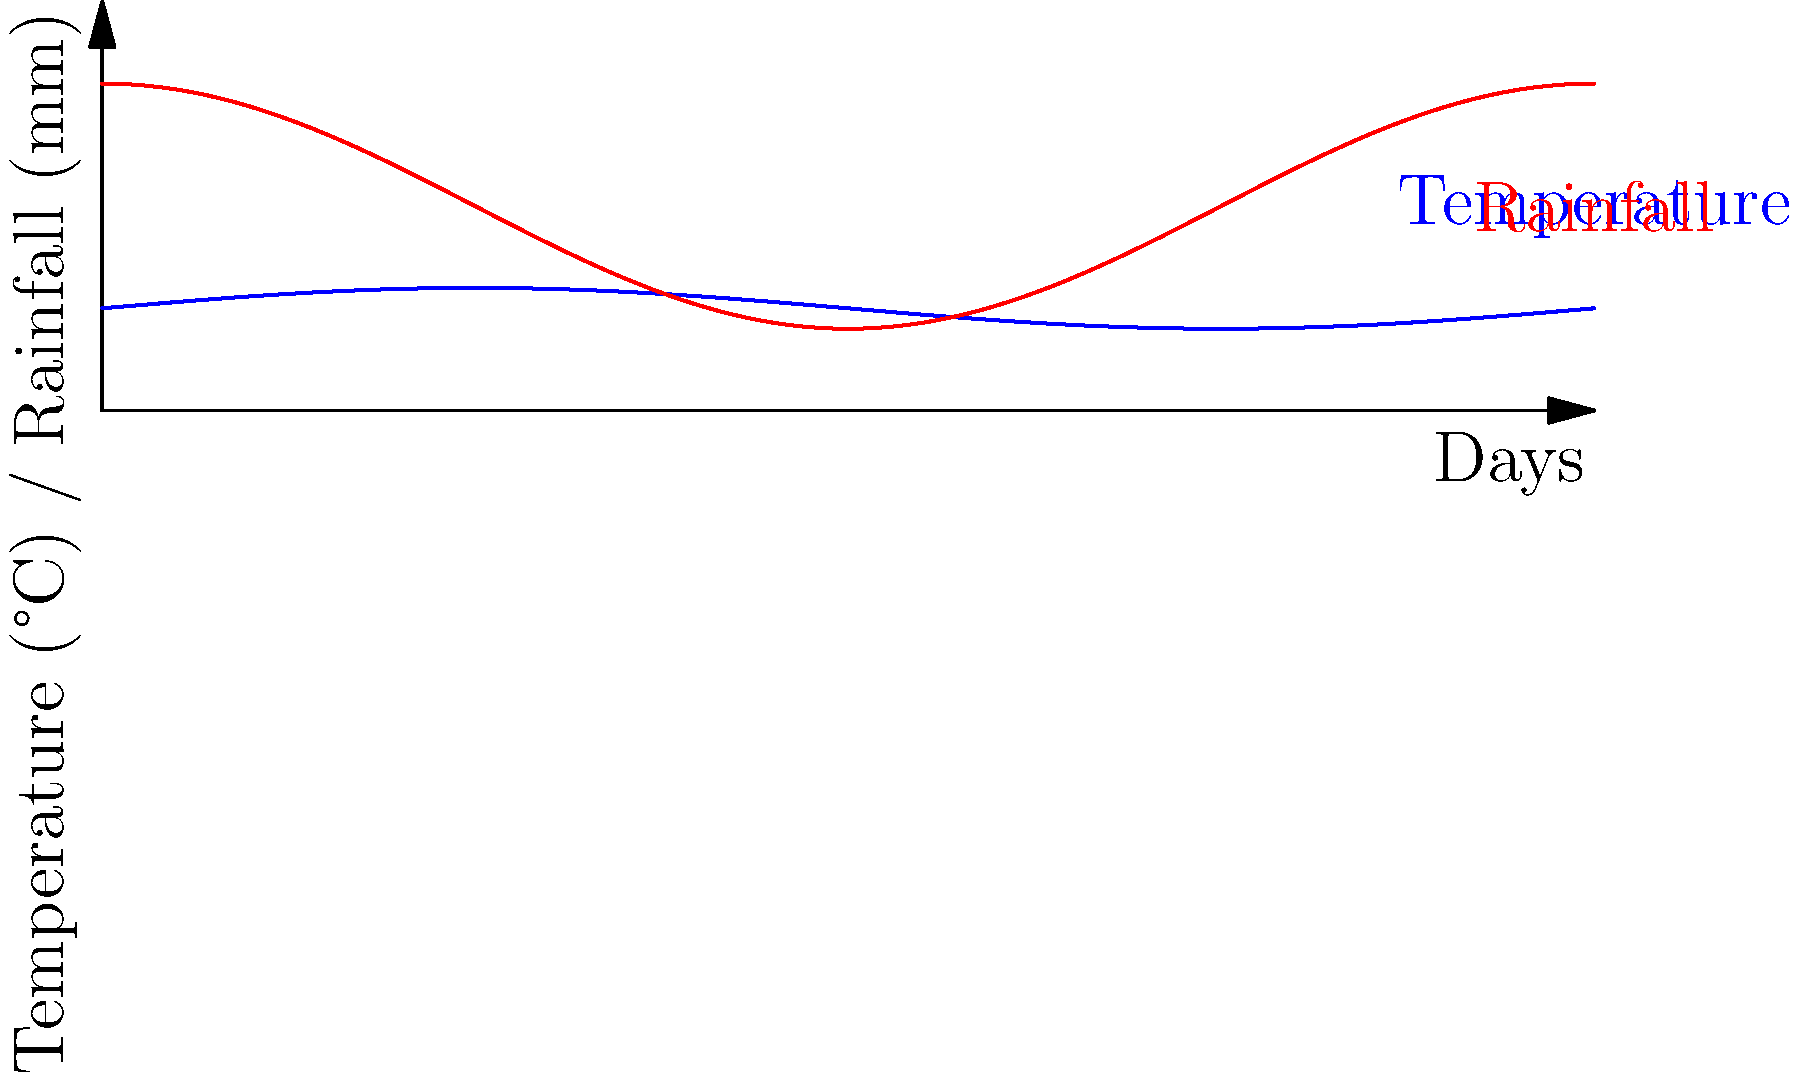As a farmer using genetically modified crops, you're analyzing the relationship between weather patterns and crop yield. The graph shows sinusoidal functions representing temperature (blue) and rainfall (red) over a year. The temperature function is given by $T(d) = 25 + 5\sin(\frac{2\pi d}{365})$, where $T$ is temperature in °C and $d$ is the day of the year. If your GM crop's yield is optimized when the temperature is at its maximum and rainfall is at 50% of its range, on which day of the year should you expect the highest yield? To solve this problem, we need to follow these steps:

1) First, let's identify when the temperature is at its maximum:
   The temperature function is $T(d) = 25 + 5\sin(\frac{2\pi d}{365})$
   This function reaches its maximum when $\sin(\frac{2\pi d}{365}) = 1$
   This occurs when $\frac{2\pi d}{365} = \frac{\pi}{2}$, or $d = \frac{365}{4} = 91.25$

2) Now, we need to check if the rainfall is at 50% of its range on this day:
   The rainfall function appears to be $R(d) = 50 + 30\sin(\frac{2\pi d}{365} + \frac{\pi}{2})$
   The range of rainfall is from 20mm to 80mm, so 50% of this range is 50mm

3) Let's calculate the rainfall on day 91.25:
   $R(91.25) = 50 + 30\sin(\frac{2\pi (91.25)}{365} + \frac{\pi}{2})$
   $= 50 + 30\sin(\frac{\pi}{2} + \frac{\pi}{2}) = 50 + 30\sin(\pi) = 50$

4) This confirms that on day 91.25, the temperature is at its maximum and the rainfall is at 50% of its range.

5) Since we need to provide a whole number of days, we round 91.25 to 91.
Answer: 91 